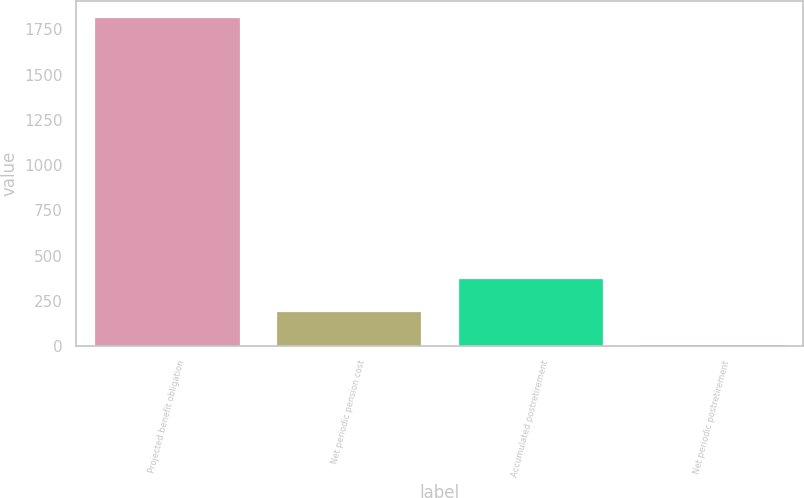<chart> <loc_0><loc_0><loc_500><loc_500><bar_chart><fcel>Projected benefit obligation<fcel>Net periodic pension cost<fcel>Accumulated postretirement<fcel>Net periodic postretirement<nl><fcel>1817<fcel>194.3<fcel>374.6<fcel>14<nl></chart> 